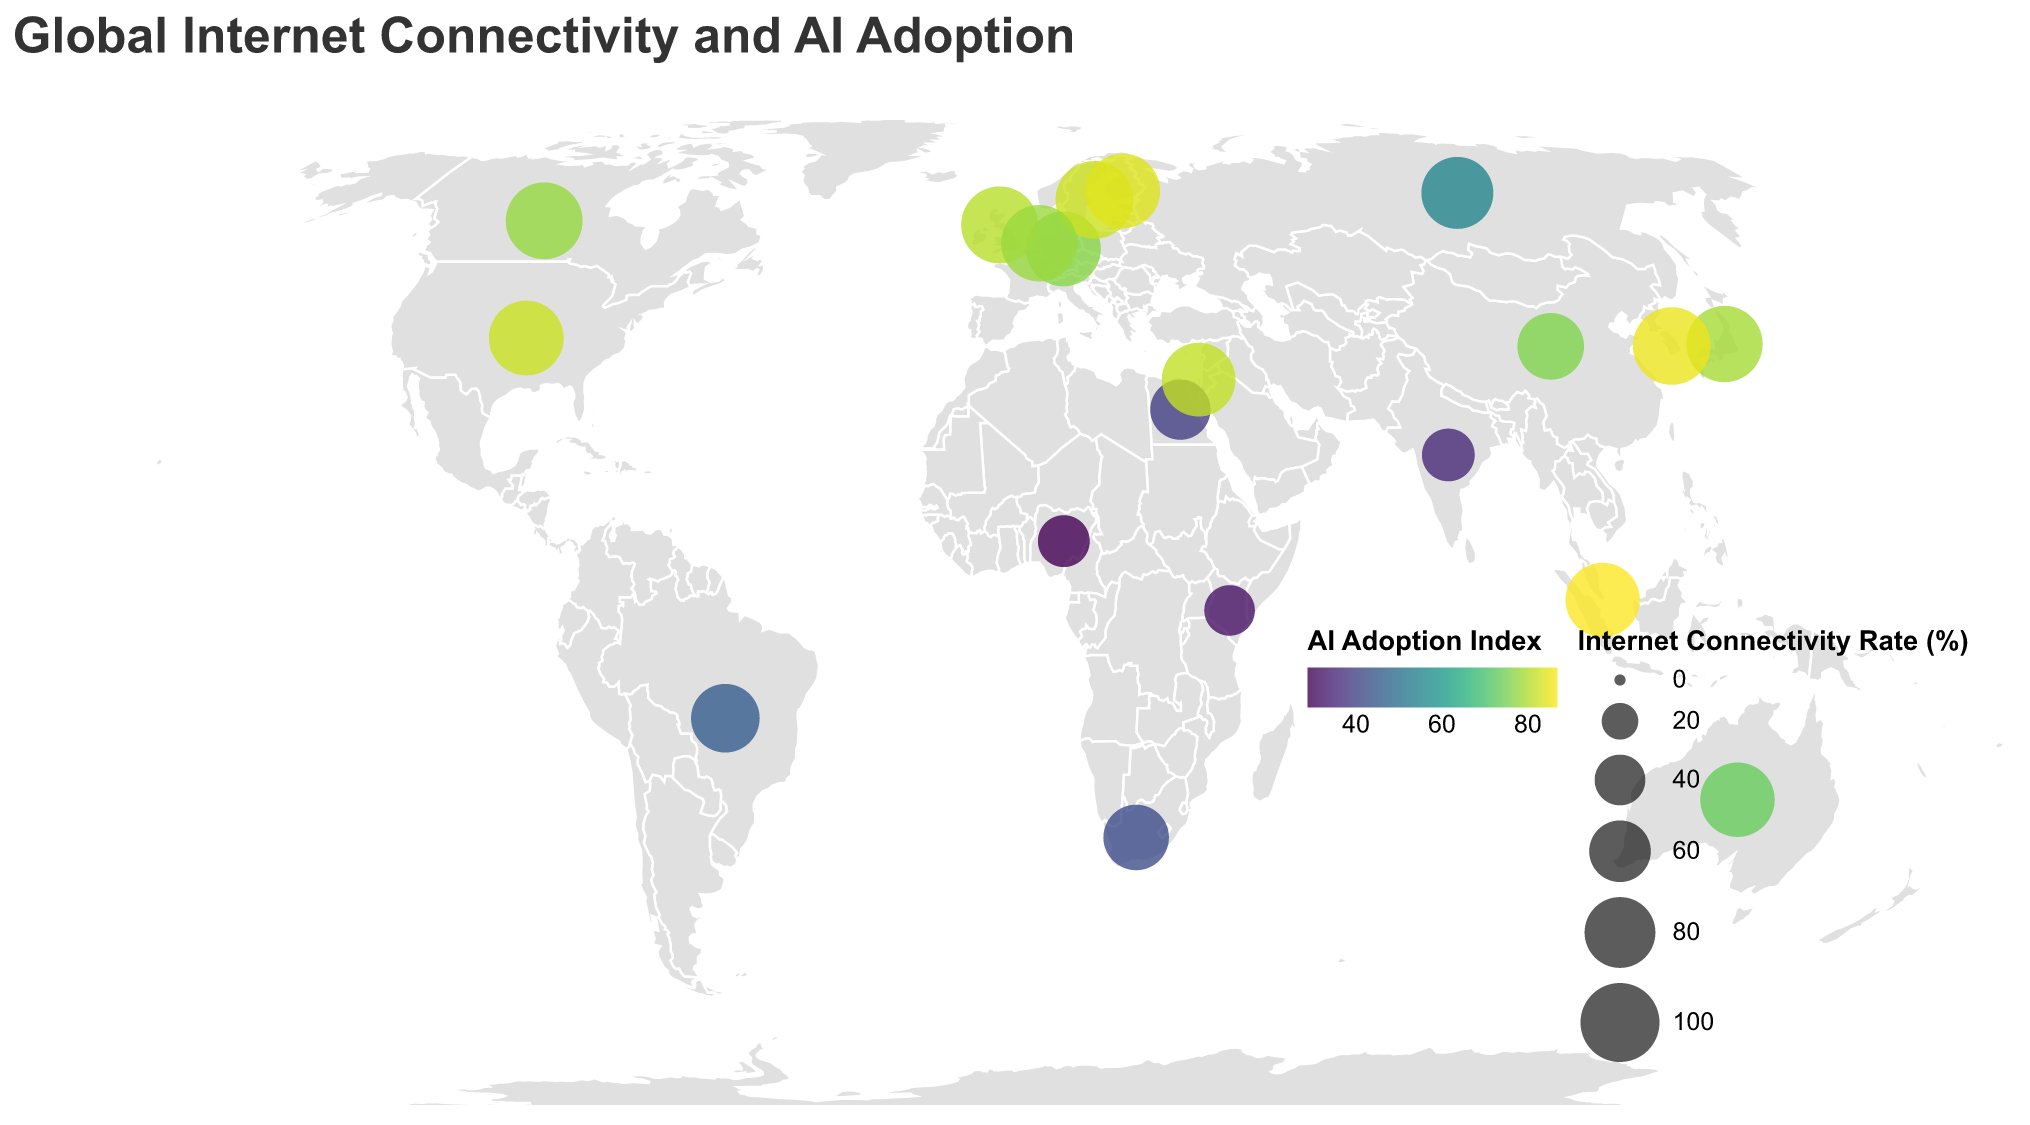What's the title of the figure? The title is directly displayed at the top of the figure and is easily readable.
Answer: Global Internet Connectivity and AI Adoption How is the internet connectivity rate represented in the plot? The internet connectivity rate is depicted by the size of the circles on the map. Larger circles indicate higher connectivity rates, while smaller circles indicate lower rates.
Answer: Circle size How can you identify countries with a high AI adoption index in the figure? Countries with a high AI adoption index are represented by darker colors in the viridis color scheme, progressing from yellow (low) to purple (high).
Answer: Darker colors Which country has the highest internet connectivity rate? By observing the size of circles, the largest circle corresponds to South Korea and Sweden, both of which have an internet connectivity rate of 96.7%.
Answer: South Korea and Sweden Which country has the lowest AI adoption index, and what is its corresponding internet connectivity rate? Nigeria has the lowest AI adoption index as indicated by the lightest color for its circle, with a corresponding AI adoption index of 28.7% and an internet connectivity rate of 42.0%.
Answer: Nigeria; 42.0% What's the average internet connectivity rate for Canada and Australia? Sum the internet connectivity rates for Canada (94.3%) and Australia (88.5%) and then divide by 2. (94.3 + 88.5) / 2 = 91.4
Answer: 91.4 Compare the AI adoption index of China and Germany. Which country has a higher index? China has an AI adoption index of 75.8%, while Germany has 76.5%. Therefore, Germany has a slightly higher AI adoption index.
Answer: Germany What is the internet connectivity rate for Israel, and how does its AI adoption index compare to the United States? Israel has an internet connectivity rate of 86.8%. Its AI adoption index is 81.6%, which is slightly lower than that of the United States at 82.3%.
Answer: 86.8%; Slightly lower Which two countries have AI adoption indices greater than 85? Look at the colors of all the circles and the tooltip: South Korea (85.2%) and Singapore (86.9%) have AI adoption indices above 85.
Answer: South Korea and Singapore What is the correlation between internet connectivity rates and AI adoption indices across the countries displayed? By observing the sizes of the circles (internet connectivity) and their colors (AI adoption), countries with higher internet connectivity rates tend to have higher AI adoption indices, indicating a positive correlation.
Answer: Positive correlation 